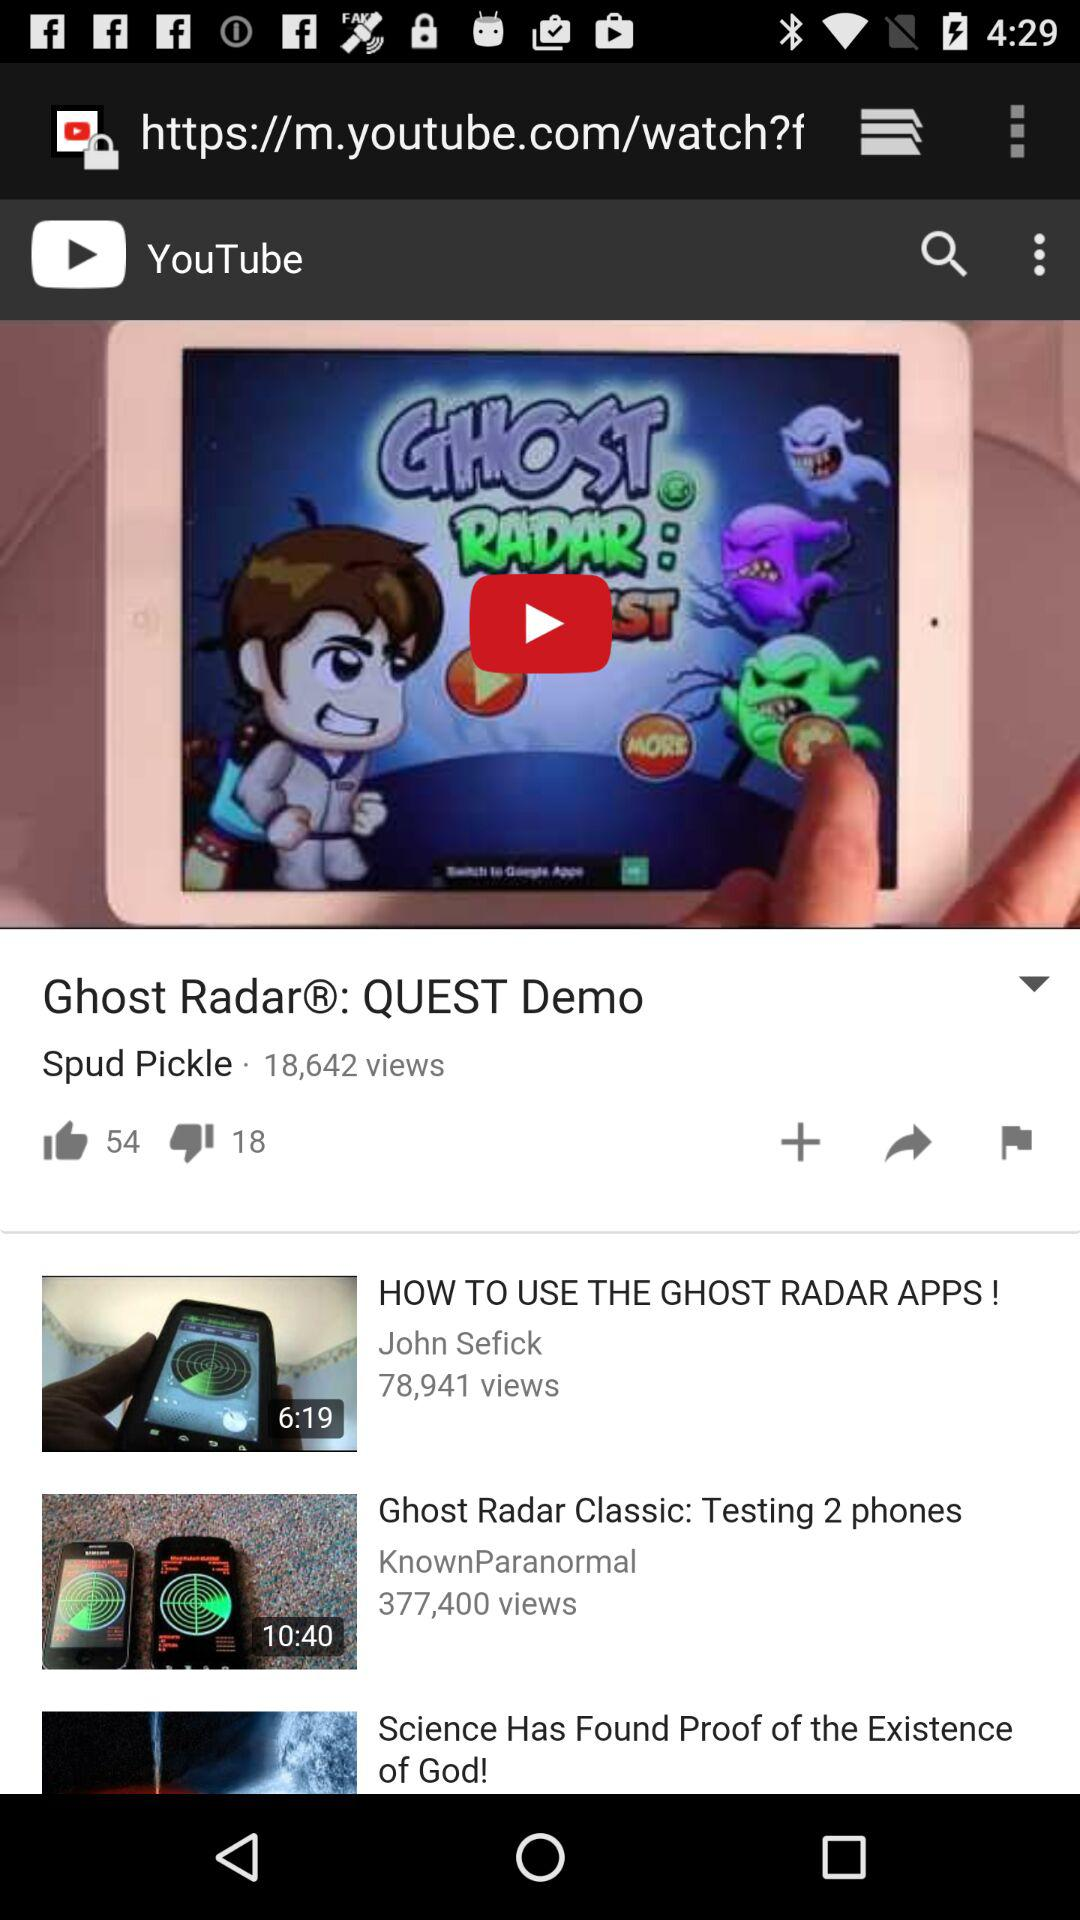John Sefick is the author of which video?
When the provided information is insufficient, respond with <no answer>. <no answer> 